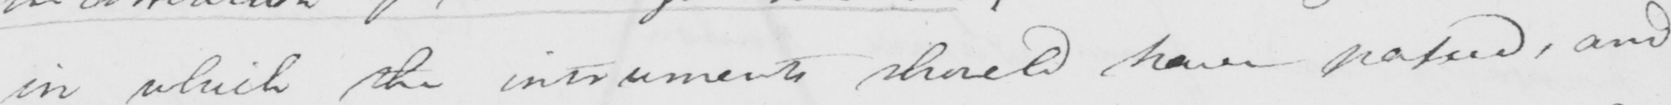Transcribe the text shown in this historical manuscript line. in which the instruments should have passed , and 